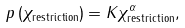<formula> <loc_0><loc_0><loc_500><loc_500>p \left ( \chi _ { \text {restriction} } \right ) = K \chi _ { \text {restriction} } ^ { \alpha } ,</formula> 